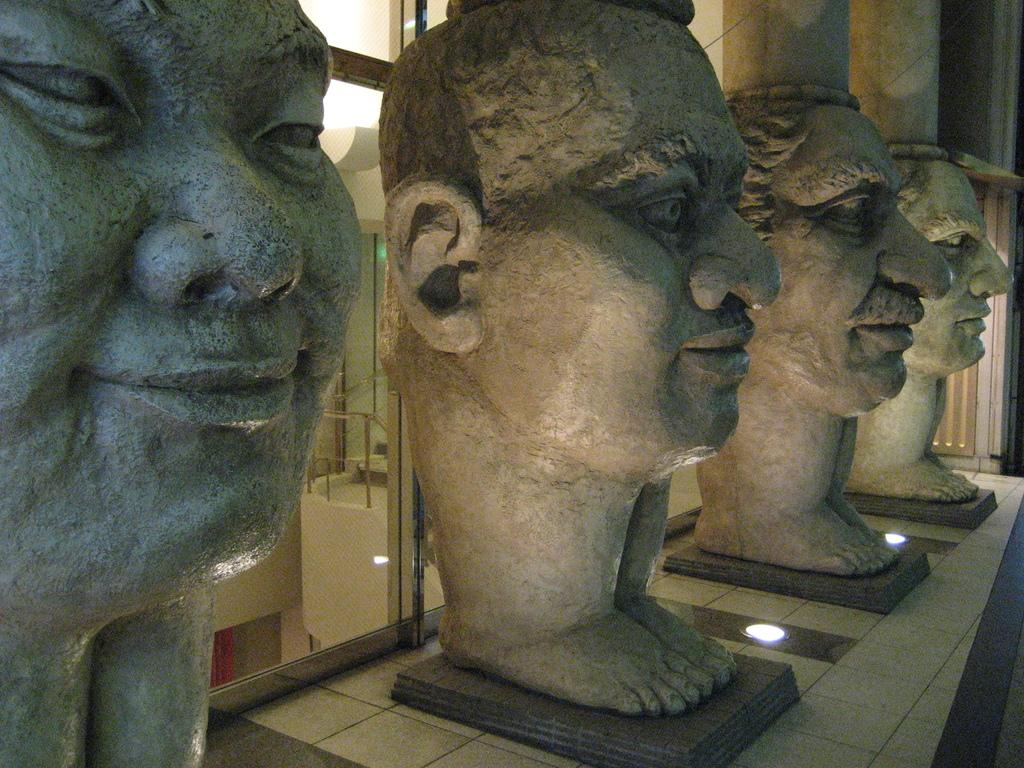What is displayed on the wall in the image? There are sculptures on a platform on the wall. What can be seen on the floor in the image? There are lights on the floor. What is behind the lights on the floor? There are glass doors behind the lights. What is visible through the glass doors? The glass doors provide a view of a wall and metal objects. Can you tell me how many lawyers are visible through the glass doors in the image? There are no lawyers visible through the glass doors in the image; it only shows a wall and metal objects. Is there a ship visible through the glass doors in the image? There is no ship visible through the glass doors in the image; it only shows a wall and metal objects. 